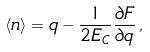Convert formula to latex. <formula><loc_0><loc_0><loc_500><loc_500>\langle n \rangle = q - \frac { 1 } { 2 E _ { C } } \frac { \partial F } { \partial q } \, ,</formula> 